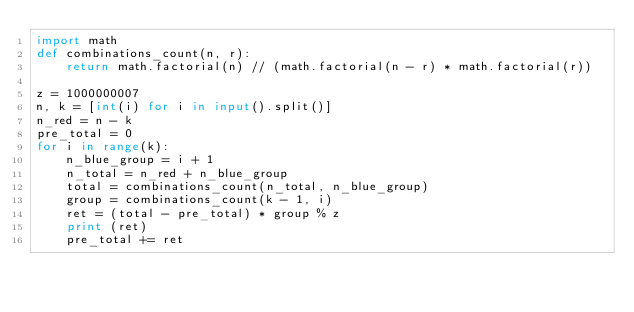<code> <loc_0><loc_0><loc_500><loc_500><_Python_>import math
def combinations_count(n, r):
    return math.factorial(n) // (math.factorial(n - r) * math.factorial(r))

z = 1000000007
n, k = [int(i) for i in input().split()]
n_red = n - k
pre_total = 0
for i in range(k):
	n_blue_group = i + 1
	n_total = n_red + n_blue_group
	total = combinations_count(n_total, n_blue_group)
	group = combinations_count(k - 1, i)
	ret = (total - pre_total) * group % z
	print (ret)
	pre_total += ret</code> 